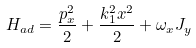Convert formula to latex. <formula><loc_0><loc_0><loc_500><loc_500>H _ { a d } = \frac { p _ { x } ^ { 2 } } { 2 } + \frac { k _ { 1 } ^ { 2 } x ^ { 2 } } { 2 } + \omega _ { x } J _ { y }</formula> 